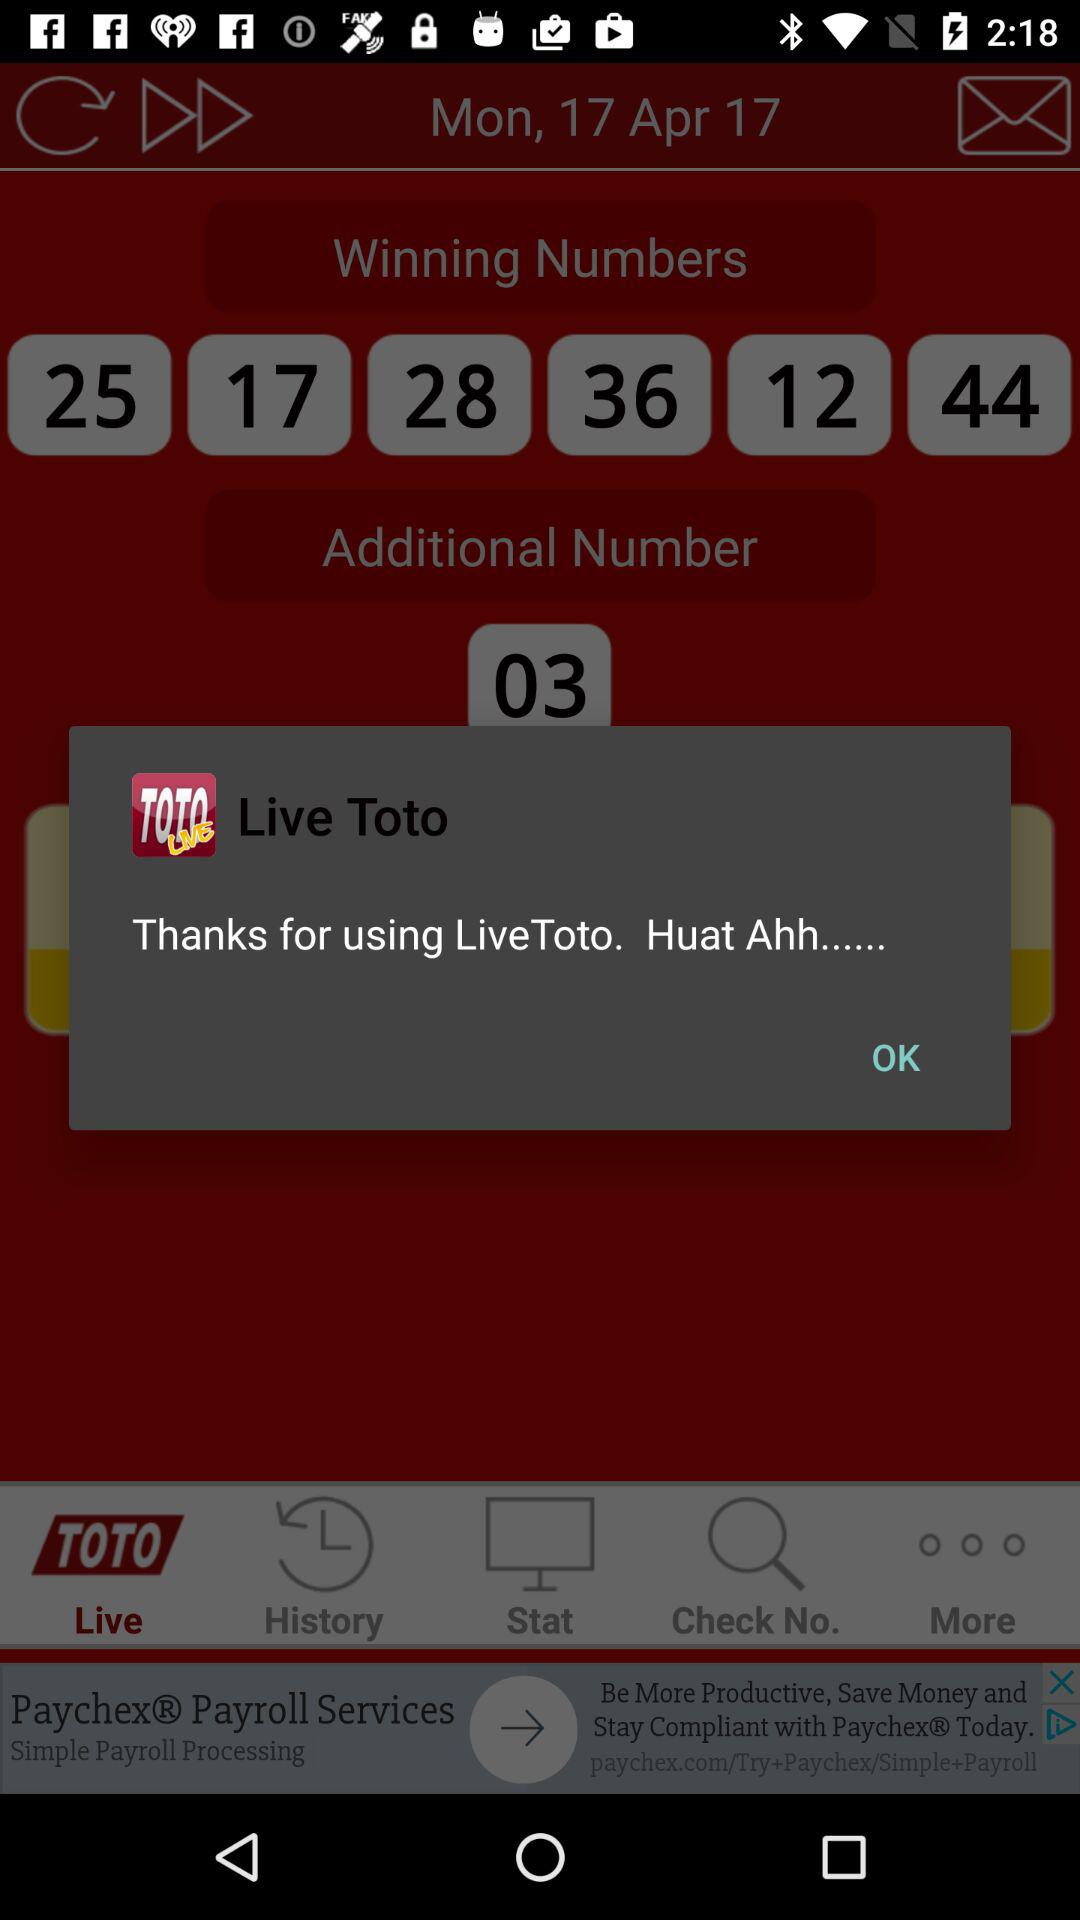What is the given day? The given day is Monday. 